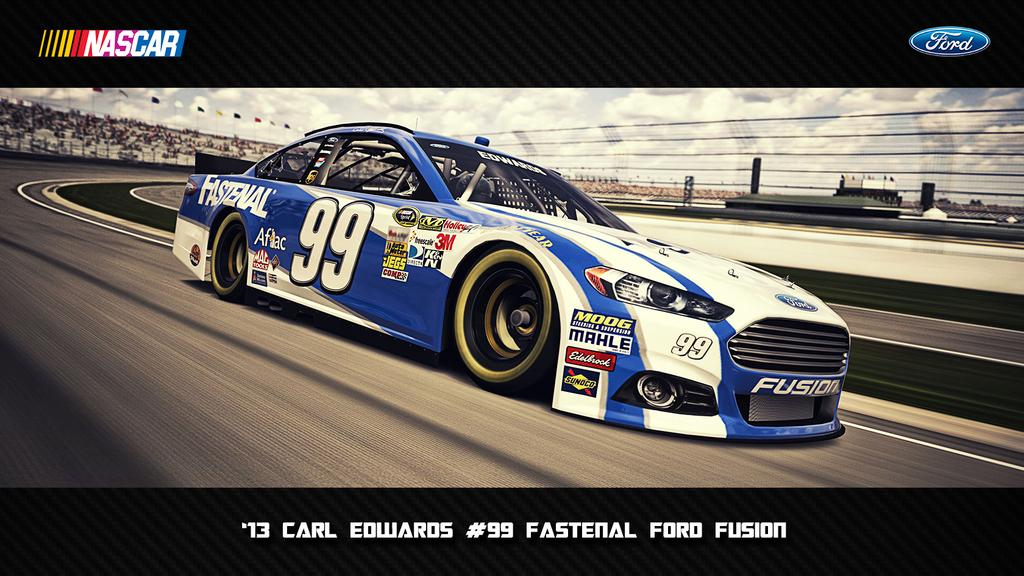What is the main subject of the image? There is a car on the road in the image. What else can be seen in the image besides the car? There are flags, a fence, logos, and objects visible in the image. What is the condition of the sky in the background of the image? The sky with clouds is visible in the background of the image. What type of string can be seen connecting the car to the flags in the image? There is no string connecting the car to the flags in the image. 